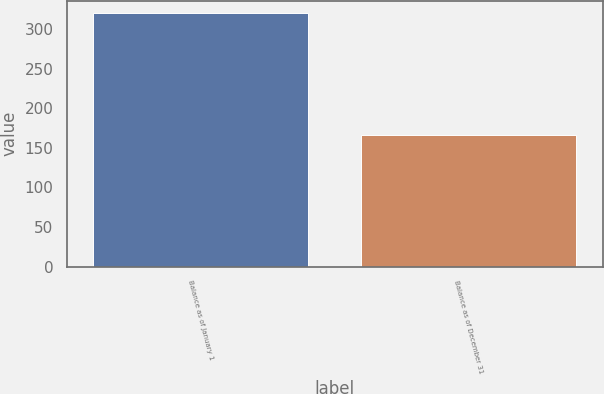Convert chart to OTSL. <chart><loc_0><loc_0><loc_500><loc_500><bar_chart><fcel>Balance as of January 1<fcel>Balance as of December 31<nl><fcel>320<fcel>166<nl></chart> 